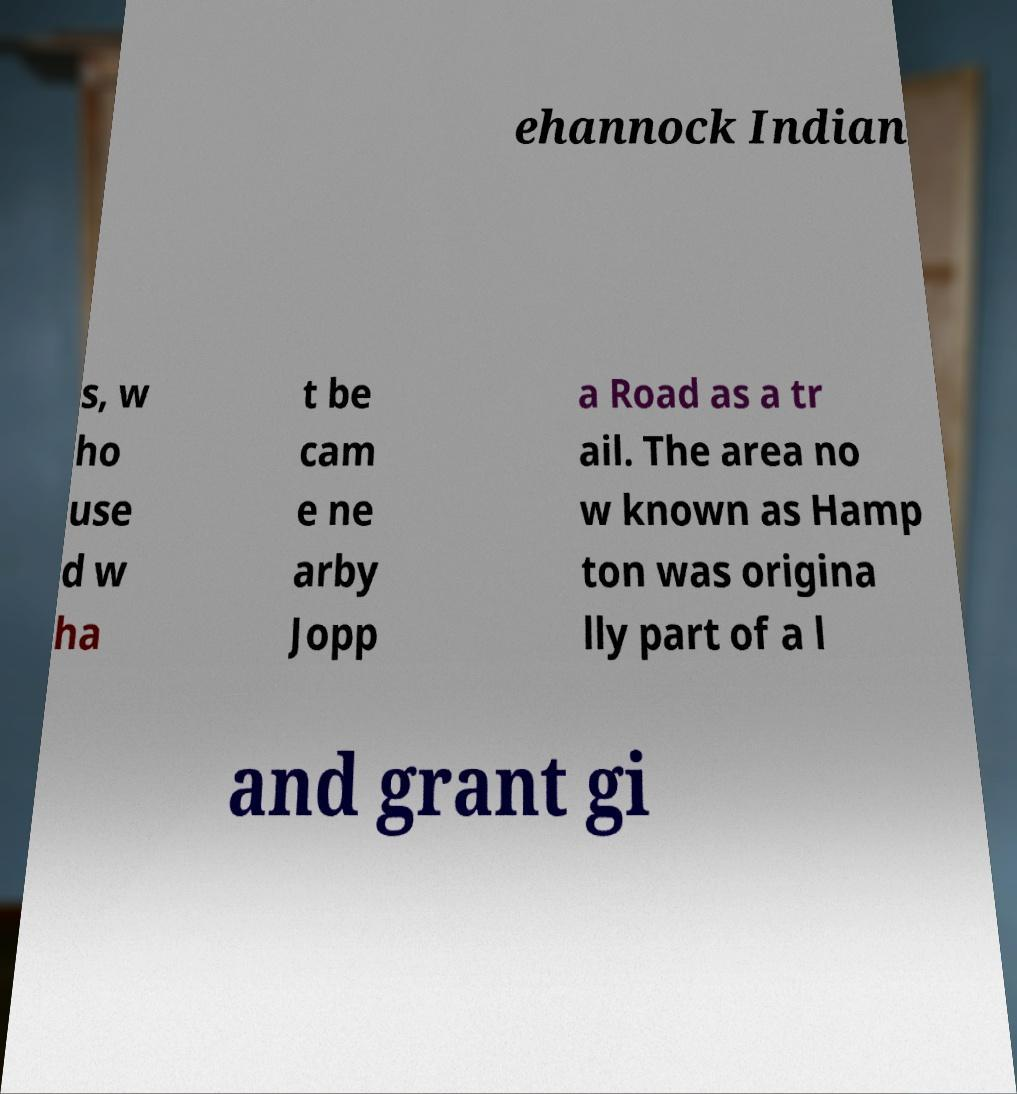Can you read and provide the text displayed in the image?This photo seems to have some interesting text. Can you extract and type it out for me? ehannock Indian s, w ho use d w ha t be cam e ne arby Jopp a Road as a tr ail. The area no w known as Hamp ton was origina lly part of a l and grant gi 